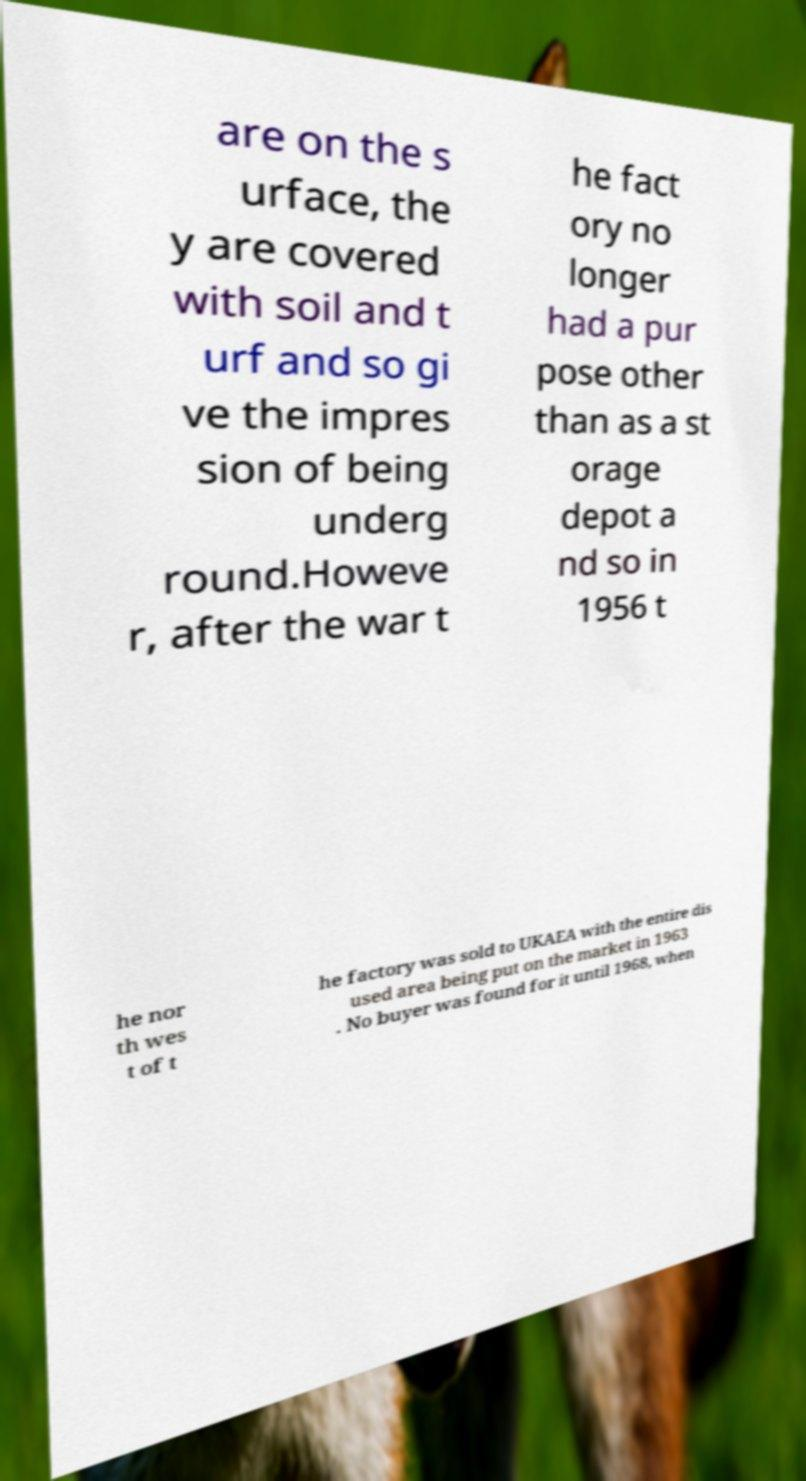There's text embedded in this image that I need extracted. Can you transcribe it verbatim? are on the s urface, the y are covered with soil and t urf and so gi ve the impres sion of being underg round.Howeve r, after the war t he fact ory no longer had a pur pose other than as a st orage depot a nd so in 1956 t he nor th wes t of t he factory was sold to UKAEA with the entire dis used area being put on the market in 1963 . No buyer was found for it until 1968, when 